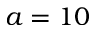Convert formula to latex. <formula><loc_0><loc_0><loc_500><loc_500>a = 1 0</formula> 